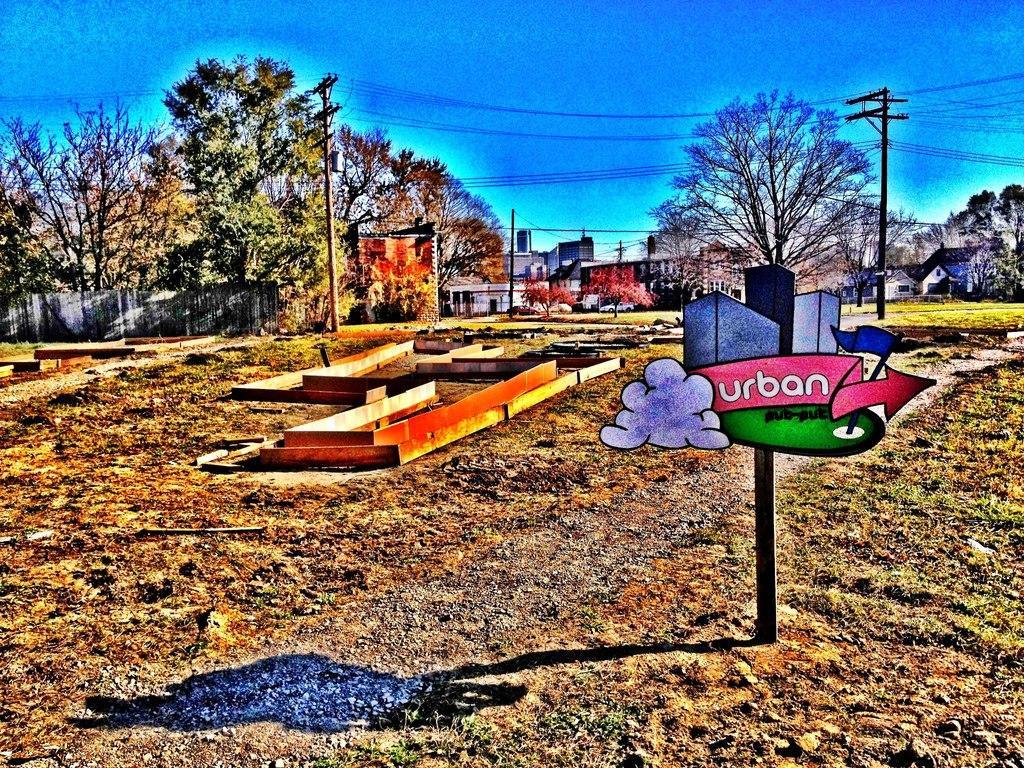Please provide a concise description of this image. This image looks like an edited photo in which I can see grass, stones, light poles, boards, metal rods, trees and wall fence. In the background I can see houses, buildings, vehicles on the road, plants and the sky. 